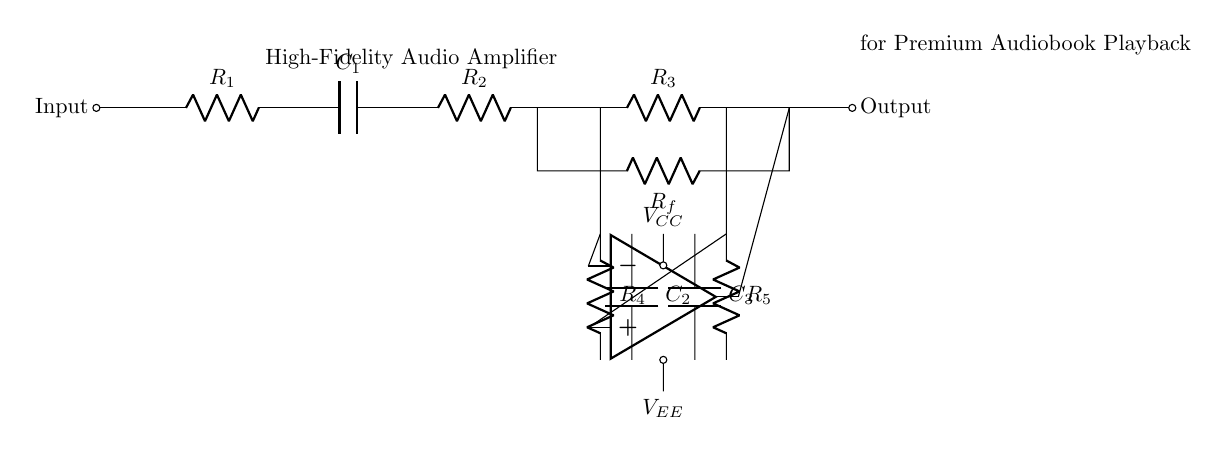What is the input component? The input component is a resistor labeled R1, which is the first component in the circuit after the input signal connection.
Answer: R1 How many capacitors are in the circuit? There are three capacitors labeled C1, C2, and C3. They are located at different points in the circuit for coupling and decoupling purposes.
Answer: 3 What is the function of the operational amplifier? The operational amplifier amplifies the difference between its two input voltages; it receives signals from the resistors R4 and R5 and outputs the amplified signal.
Answer: Amplification What is the total resistance in the feedback network? The resistance in the feedback network is determined by Rf connected in parallel to the resistors that precede it. To find the total resistance, one would typically use the formula for resistors in parallel, but here it is only represented by Rf.
Answer: Rf What is the purpose of the decoupling capacitors C2 and C3? The decoupling capacitors C2 and C3 serve to filter out high-frequency noise from the power supply voltage, stabilizing the circuit operation by providing a low-impedance path to ground for AC noise.
Answer: Noise filtering What are the power supply voltages in the circuit? The voltage supplies in the circuit are VCC and VEE, both essential for providing appropriate voltage levels to the operational amplifier and ensuring proper amplification of the audio signal.
Answer: VCC and VEE 